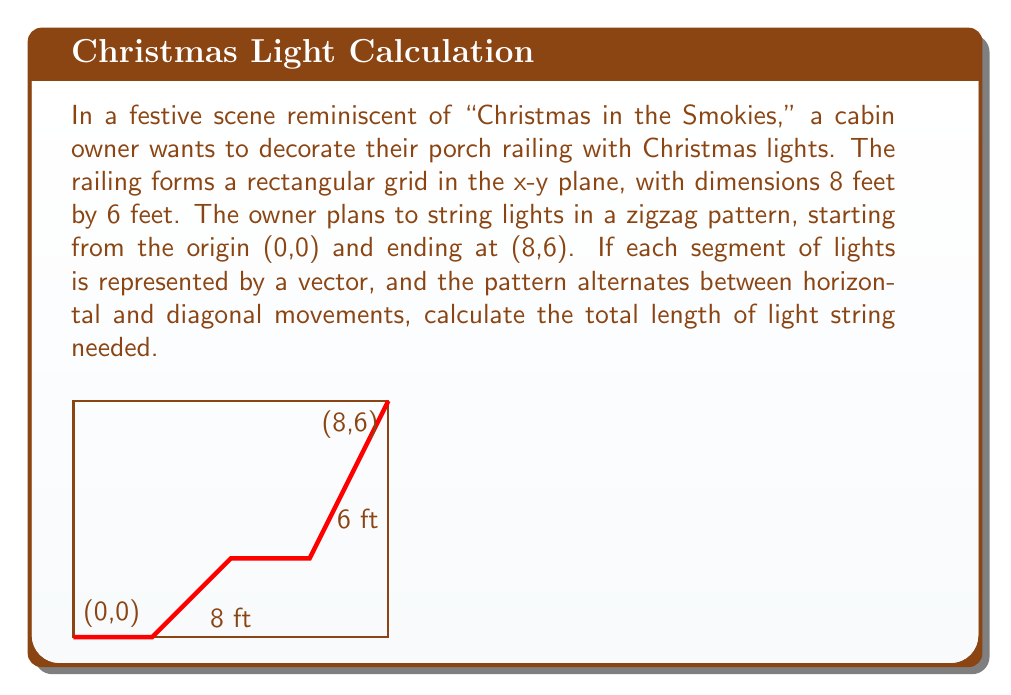Help me with this question. Let's approach this step-by-step:

1) The zigzag pattern consists of 4 vectors: 2 horizontal and 2 diagonal.

2) Horizontal vectors:
   - $\vec{v_1} = (2,0)$
   - $\vec{v_3} = (2,0)$

3) Diagonal vectors:
   - $\vec{v_2} = (2,2)$
   - $\vec{v_4} = (2,4)$

4) Calculate the magnitudes of these vectors:

   For horizontal vectors:
   $|\vec{v_1}| = |\vec{v_3}| = \sqrt{2^2 + 0^2} = 2$ feet

   For diagonal vectors:
   $|\vec{v_2}| = \sqrt{2^2 + 2^2} = 2\sqrt{2}$ feet
   $|\vec{v_4}| = \sqrt{2^2 + 4^2} = \sqrt{20}$ feet

5) Sum up all the magnitudes:

   Total length = $2 + 2\sqrt{2} + 2 + \sqrt{20}$ feet

6) Simplify:
   $= 4 + 2\sqrt{2} + \sqrt{20}$ feet
   $= 4 + 2\sqrt{2} + 2\sqrt{5}$ feet

This is the exact length needed for the light string.
Answer: $4 + 2\sqrt{2} + 2\sqrt{5}$ feet 